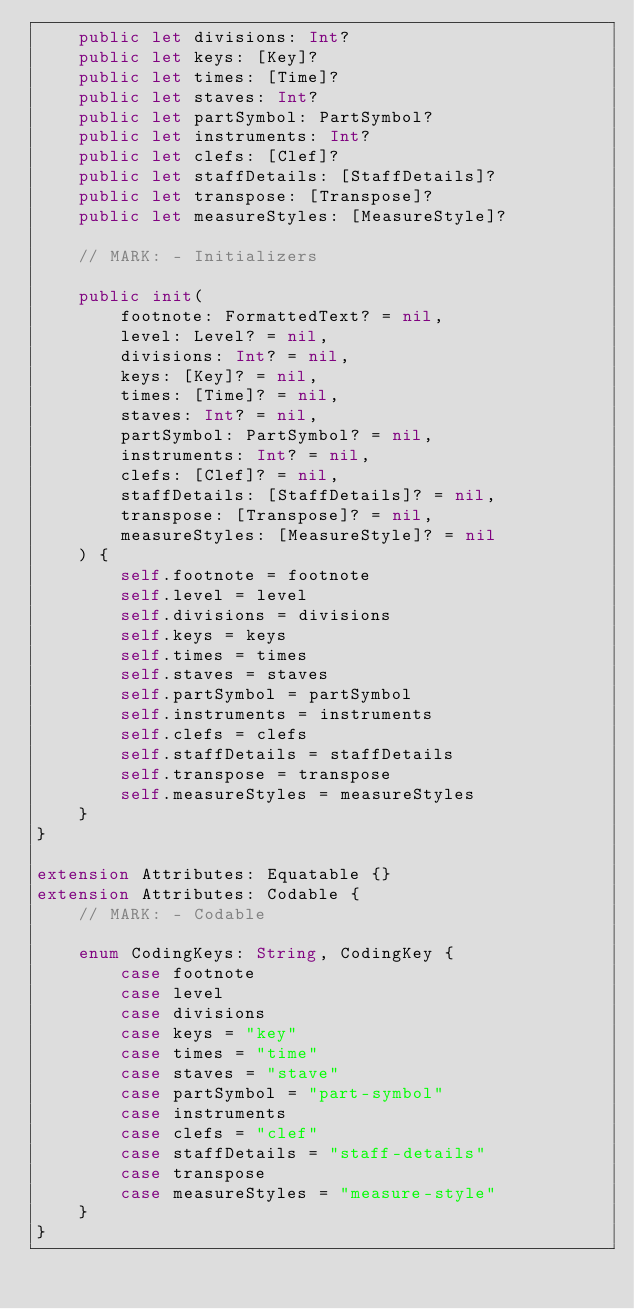<code> <loc_0><loc_0><loc_500><loc_500><_Swift_>    public let divisions: Int?
    public let keys: [Key]?
    public let times: [Time]?
    public let staves: Int?
    public let partSymbol: PartSymbol?
    public let instruments: Int?
    public let clefs: [Clef]?
    public let staffDetails: [StaffDetails]?
    public let transpose: [Transpose]?
    public let measureStyles: [MeasureStyle]?

    // MARK: - Initializers

    public init(
        footnote: FormattedText? = nil,
        level: Level? = nil,
        divisions: Int? = nil,
        keys: [Key]? = nil,
        times: [Time]? = nil,
        staves: Int? = nil,
        partSymbol: PartSymbol? = nil,
        instruments: Int? = nil,
        clefs: [Clef]? = nil,
        staffDetails: [StaffDetails]? = nil,
        transpose: [Transpose]? = nil,
        measureStyles: [MeasureStyle]? = nil
    ) {
        self.footnote = footnote
        self.level = level
        self.divisions = divisions
        self.keys = keys
        self.times = times
        self.staves = staves
        self.partSymbol = partSymbol
        self.instruments = instruments
        self.clefs = clefs
        self.staffDetails = staffDetails
        self.transpose = transpose
        self.measureStyles = measureStyles
    }
}

extension Attributes: Equatable {}
extension Attributes: Codable {
    // MARK: - Codable

    enum CodingKeys: String, CodingKey {
        case footnote
        case level
        case divisions
        case keys = "key"
        case times = "time"
        case staves = "stave"
        case partSymbol = "part-symbol"
        case instruments
        case clefs = "clef"
        case staffDetails = "staff-details"
        case transpose
        case measureStyles = "measure-style"
    }
}
</code> 